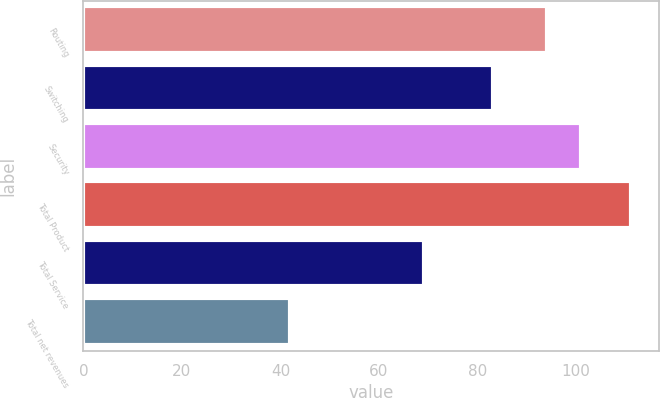Convert chart to OTSL. <chart><loc_0><loc_0><loc_500><loc_500><bar_chart><fcel>Routing<fcel>Switching<fcel>Security<fcel>Total Product<fcel>Total Service<fcel>Total net revenues<nl><fcel>94.1<fcel>83.2<fcel>101.02<fcel>111.2<fcel>69.2<fcel>42<nl></chart> 